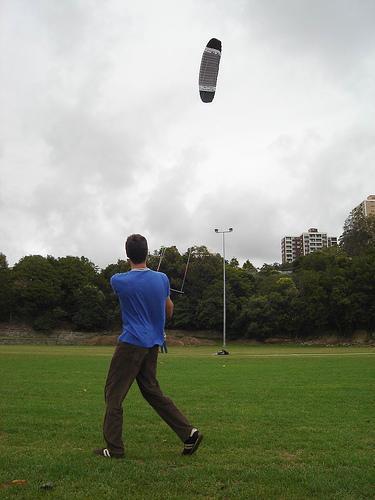How many people are flying a kite?
Give a very brief answer. 1. 